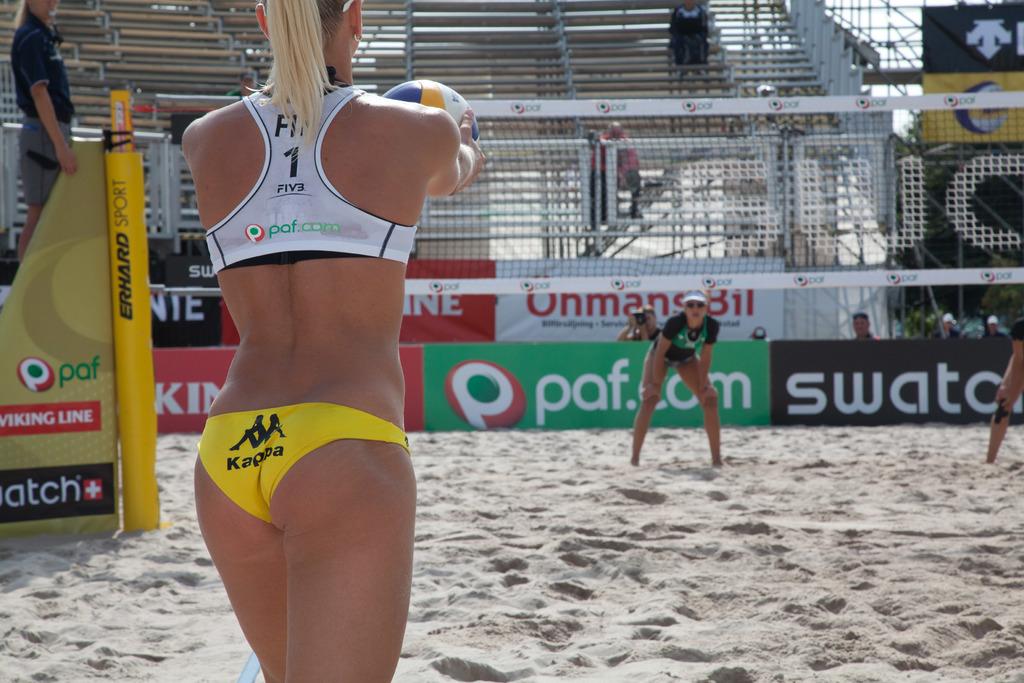What number does it say on the woman's white top?
Provide a short and direct response. 1. 